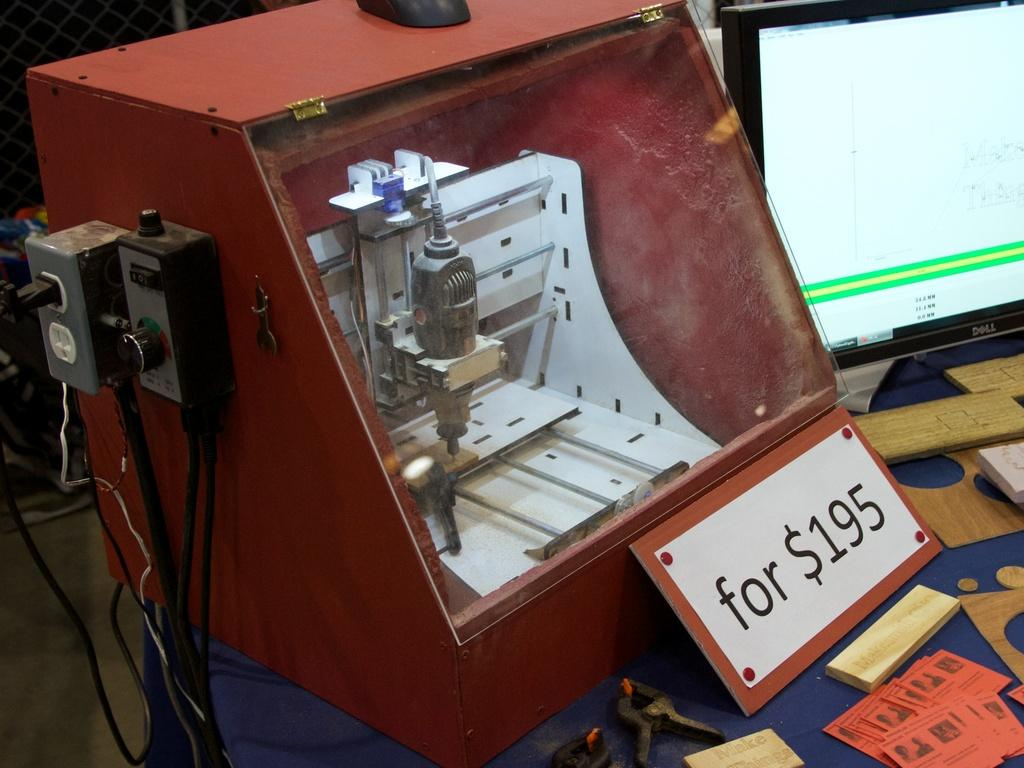<image>
Present a compact description of the photo's key features. The price for the tool in front of it is 195 dollars 